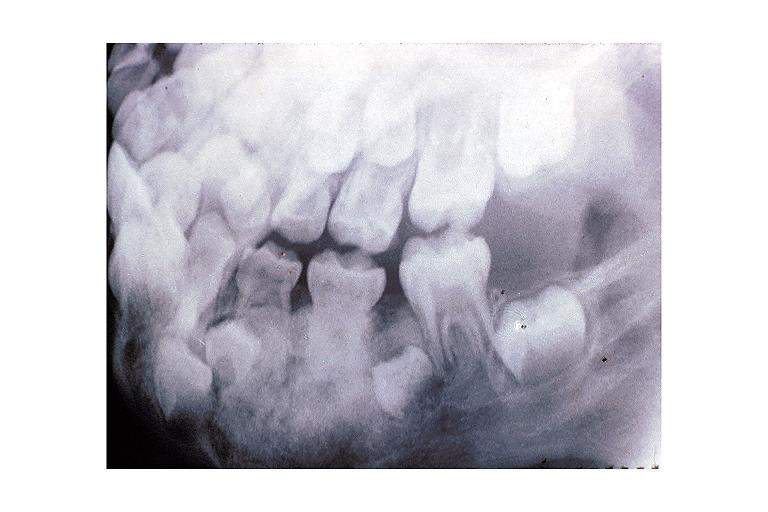s mycobacterium avium intracellulare present?
Answer the question using a single word or phrase. No 